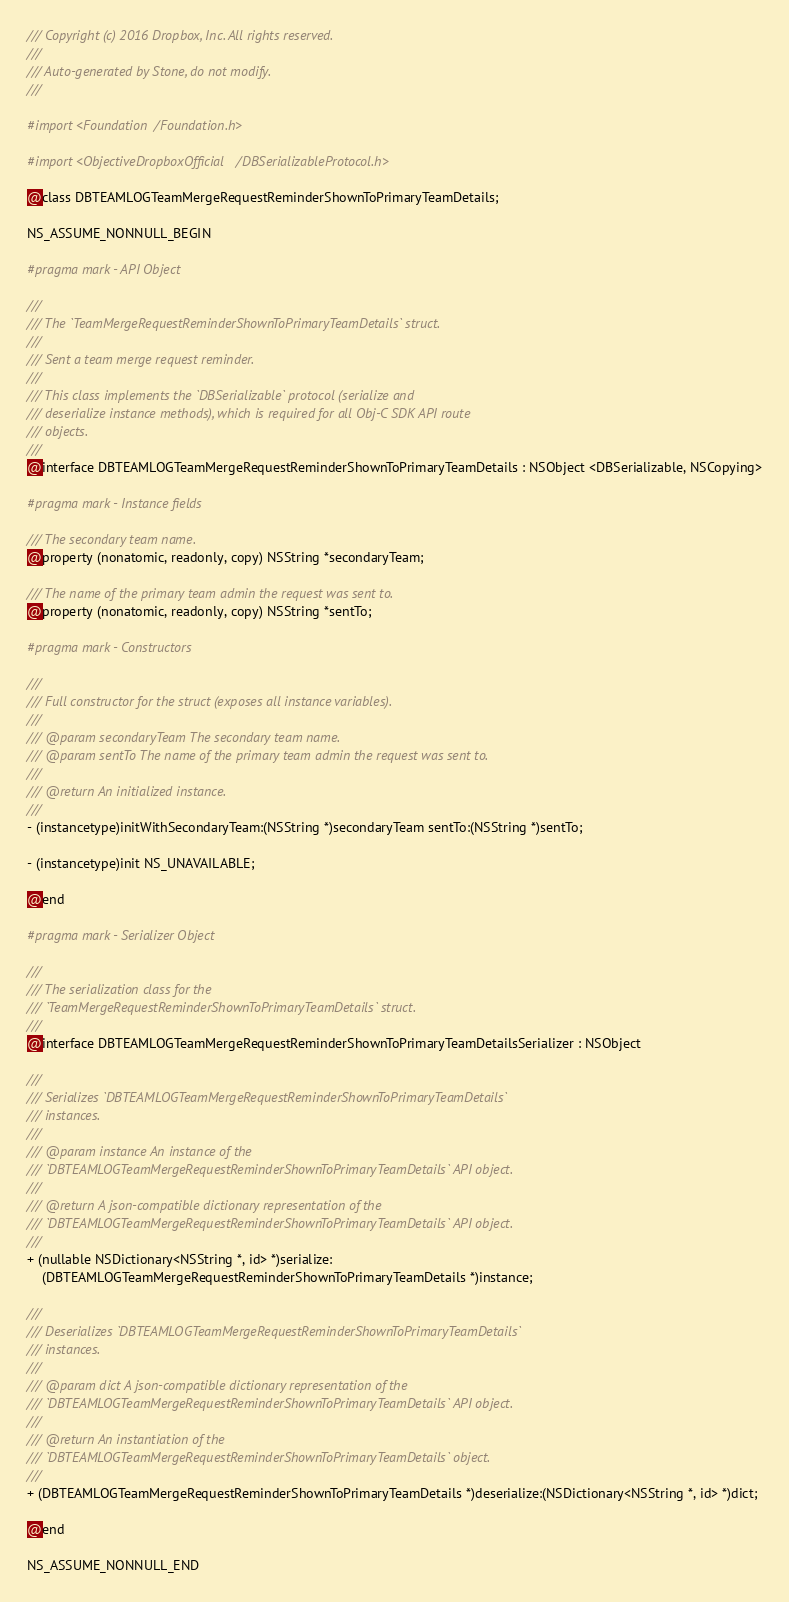<code> <loc_0><loc_0><loc_500><loc_500><_C_>/// Copyright (c) 2016 Dropbox, Inc. All rights reserved.
///
/// Auto-generated by Stone, do not modify.
///

#import <Foundation/Foundation.h>

#import <ObjectiveDropboxOfficial/DBSerializableProtocol.h>

@class DBTEAMLOGTeamMergeRequestReminderShownToPrimaryTeamDetails;

NS_ASSUME_NONNULL_BEGIN

#pragma mark - API Object

///
/// The `TeamMergeRequestReminderShownToPrimaryTeamDetails` struct.
///
/// Sent a team merge request reminder.
///
/// This class implements the `DBSerializable` protocol (serialize and
/// deserialize instance methods), which is required for all Obj-C SDK API route
/// objects.
///
@interface DBTEAMLOGTeamMergeRequestReminderShownToPrimaryTeamDetails : NSObject <DBSerializable, NSCopying>

#pragma mark - Instance fields

/// The secondary team name.
@property (nonatomic, readonly, copy) NSString *secondaryTeam;

/// The name of the primary team admin the request was sent to.
@property (nonatomic, readonly, copy) NSString *sentTo;

#pragma mark - Constructors

///
/// Full constructor for the struct (exposes all instance variables).
///
/// @param secondaryTeam The secondary team name.
/// @param sentTo The name of the primary team admin the request was sent to.
///
/// @return An initialized instance.
///
- (instancetype)initWithSecondaryTeam:(NSString *)secondaryTeam sentTo:(NSString *)sentTo;

- (instancetype)init NS_UNAVAILABLE;

@end

#pragma mark - Serializer Object

///
/// The serialization class for the
/// `TeamMergeRequestReminderShownToPrimaryTeamDetails` struct.
///
@interface DBTEAMLOGTeamMergeRequestReminderShownToPrimaryTeamDetailsSerializer : NSObject

///
/// Serializes `DBTEAMLOGTeamMergeRequestReminderShownToPrimaryTeamDetails`
/// instances.
///
/// @param instance An instance of the
/// `DBTEAMLOGTeamMergeRequestReminderShownToPrimaryTeamDetails` API object.
///
/// @return A json-compatible dictionary representation of the
/// `DBTEAMLOGTeamMergeRequestReminderShownToPrimaryTeamDetails` API object.
///
+ (nullable NSDictionary<NSString *, id> *)serialize:
    (DBTEAMLOGTeamMergeRequestReminderShownToPrimaryTeamDetails *)instance;

///
/// Deserializes `DBTEAMLOGTeamMergeRequestReminderShownToPrimaryTeamDetails`
/// instances.
///
/// @param dict A json-compatible dictionary representation of the
/// `DBTEAMLOGTeamMergeRequestReminderShownToPrimaryTeamDetails` API object.
///
/// @return An instantiation of the
/// `DBTEAMLOGTeamMergeRequestReminderShownToPrimaryTeamDetails` object.
///
+ (DBTEAMLOGTeamMergeRequestReminderShownToPrimaryTeamDetails *)deserialize:(NSDictionary<NSString *, id> *)dict;

@end

NS_ASSUME_NONNULL_END
</code> 